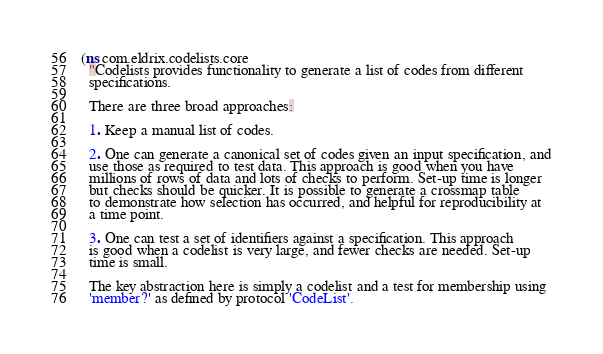Convert code to text. <code><loc_0><loc_0><loc_500><loc_500><_Clojure_>(ns com.eldrix.codelists.core
  "Codelists provides functionality to generate a list of codes from different
  specifications.

  There are three broad approaches:

  1. Keep a manual list of codes.

  2. One can generate a canonical set of codes given an input specification, and
  use those as required to test data. This approach is good when you have
  millions of rows of data and lots of checks to perform. Set-up time is longer
  but checks should be quicker. It is possible to generate a crossmap table
  to demonstrate how selection has occurred, and helpful for reproducibility at
  a time point.

  3. One can test a set of identifiers against a specification. This approach
  is good when a codelist is very large, and fewer checks are needed. Set-up
  time is small.

  The key abstraction here is simply a codelist and a test for membership using
  'member?' as defined by protocol 'CodeList'.
</code> 